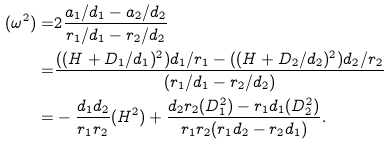Convert formula to latex. <formula><loc_0><loc_0><loc_500><loc_500>( \omega ^ { 2 } ) = & 2 \frac { a _ { 1 } / d _ { 1 } - a _ { 2 } / d _ { 2 } } { r _ { 1 } / d _ { 1 } - r _ { 2 } / d _ { 2 } } \\ = & \frac { ( ( H + D _ { 1 } / d _ { 1 } ) ^ { 2 } ) d _ { 1 } / r _ { 1 } - ( ( H + D _ { 2 } / d _ { 2 } ) ^ { 2 } ) d _ { 2 } / r _ { 2 } } { ( r _ { 1 } / d _ { 1 } - r _ { 2 } / d _ { 2 } ) } \\ = & - \frac { d _ { 1 } d _ { 2 } } { r _ { 1 } r _ { 2 } } ( H ^ { 2 } ) + \frac { d _ { 2 } r _ { 2 } ( D _ { 1 } ^ { 2 } ) - r _ { 1 } d _ { 1 } ( D _ { 2 } ^ { 2 } ) } { r _ { 1 } r _ { 2 } ( r _ { 1 } d _ { 2 } - r _ { 2 } d _ { 1 } ) } .</formula> 